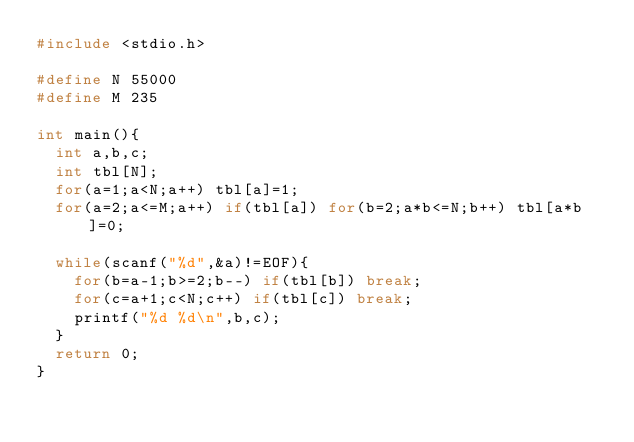Convert code to text. <code><loc_0><loc_0><loc_500><loc_500><_C_>#include <stdio.h>

#define N 55000
#define M 235

int main(){
  int a,b,c;
  int tbl[N];
  for(a=1;a<N;a++) tbl[a]=1;
  for(a=2;a<=M;a++) if(tbl[a]) for(b=2;a*b<=N;b++) tbl[a*b]=0;

  while(scanf("%d",&a)!=EOF){
    for(b=a-1;b>=2;b--) if(tbl[b]) break;
    for(c=a+1;c<N;c++) if(tbl[c]) break;
    printf("%d %d\n",b,c);
  }
  return 0;
}</code> 